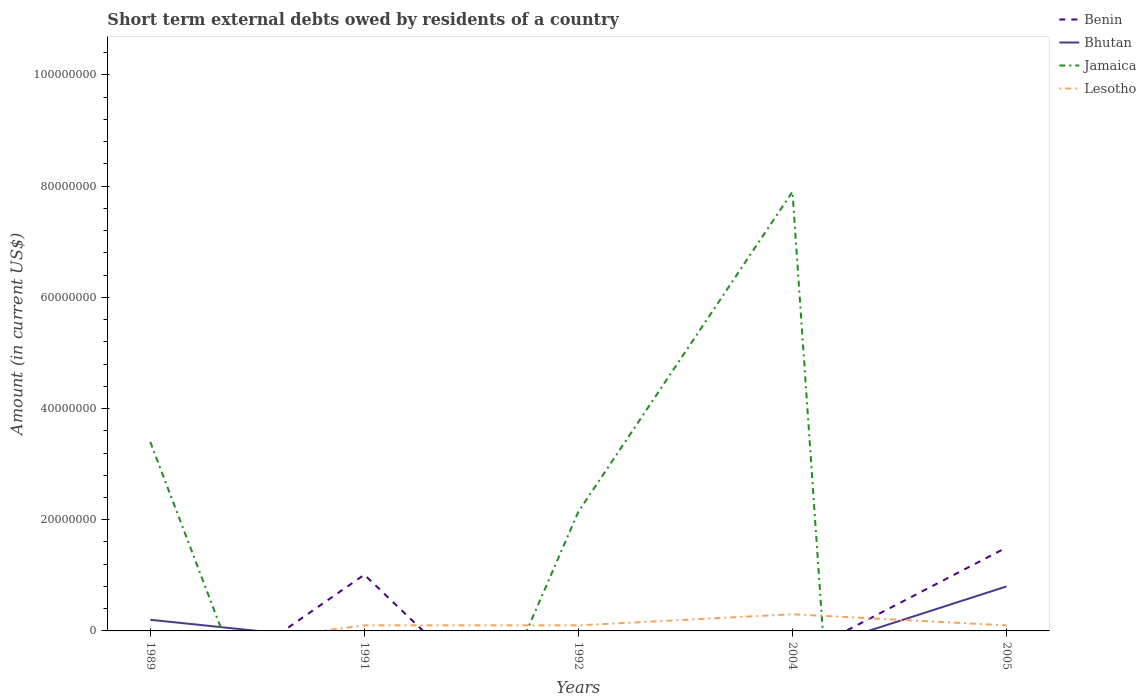How many different coloured lines are there?
Make the answer very short. 4. Does the line corresponding to Jamaica intersect with the line corresponding to Benin?
Make the answer very short. Yes. Is the number of lines equal to the number of legend labels?
Offer a very short reply. No. What is the total amount of short-term external debts owed by residents in Bhutan in the graph?
Make the answer very short. -5.99e+06. What is the difference between the highest and the second highest amount of short-term external debts owed by residents in Lesotho?
Offer a terse response. 3.00e+06. Is the amount of short-term external debts owed by residents in Lesotho strictly greater than the amount of short-term external debts owed by residents in Jamaica over the years?
Your answer should be compact. No. How many lines are there?
Offer a very short reply. 4. How many years are there in the graph?
Ensure brevity in your answer.  5. What is the difference between two consecutive major ticks on the Y-axis?
Offer a terse response. 2.00e+07. Does the graph contain any zero values?
Give a very brief answer. Yes. Does the graph contain grids?
Make the answer very short. No. How many legend labels are there?
Make the answer very short. 4. What is the title of the graph?
Make the answer very short. Short term external debts owed by residents of a country. What is the label or title of the X-axis?
Offer a very short reply. Years. What is the label or title of the Y-axis?
Provide a short and direct response. Amount (in current US$). What is the Amount (in current US$) in Benin in 1989?
Give a very brief answer. 0. What is the Amount (in current US$) in Bhutan in 1989?
Provide a succinct answer. 2.01e+06. What is the Amount (in current US$) in Jamaica in 1989?
Make the answer very short. 3.40e+07. What is the Amount (in current US$) in Benin in 1991?
Ensure brevity in your answer.  1.01e+07. What is the Amount (in current US$) in Jamaica in 1991?
Give a very brief answer. 0. What is the Amount (in current US$) of Lesotho in 1991?
Keep it short and to the point. 1.00e+06. What is the Amount (in current US$) of Bhutan in 1992?
Provide a succinct answer. 0. What is the Amount (in current US$) of Jamaica in 1992?
Give a very brief answer. 2.14e+07. What is the Amount (in current US$) of Lesotho in 1992?
Give a very brief answer. 1.00e+06. What is the Amount (in current US$) in Jamaica in 2004?
Give a very brief answer. 7.90e+07. What is the Amount (in current US$) of Lesotho in 2004?
Offer a very short reply. 3.00e+06. What is the Amount (in current US$) in Benin in 2005?
Your response must be concise. 1.50e+07. What is the Amount (in current US$) in Lesotho in 2005?
Provide a succinct answer. 1.00e+06. Across all years, what is the maximum Amount (in current US$) in Benin?
Ensure brevity in your answer.  1.50e+07. Across all years, what is the maximum Amount (in current US$) in Bhutan?
Give a very brief answer. 8.00e+06. Across all years, what is the maximum Amount (in current US$) in Jamaica?
Offer a terse response. 7.90e+07. Across all years, what is the minimum Amount (in current US$) of Benin?
Your answer should be compact. 0. Across all years, what is the minimum Amount (in current US$) of Jamaica?
Offer a very short reply. 0. What is the total Amount (in current US$) of Benin in the graph?
Make the answer very short. 2.51e+07. What is the total Amount (in current US$) in Bhutan in the graph?
Your answer should be compact. 1.00e+07. What is the total Amount (in current US$) in Jamaica in the graph?
Make the answer very short. 1.34e+08. What is the difference between the Amount (in current US$) in Jamaica in 1989 and that in 1992?
Offer a very short reply. 1.26e+07. What is the difference between the Amount (in current US$) in Jamaica in 1989 and that in 2004?
Give a very brief answer. -4.50e+07. What is the difference between the Amount (in current US$) in Bhutan in 1989 and that in 2005?
Ensure brevity in your answer.  -5.99e+06. What is the difference between the Amount (in current US$) in Lesotho in 1991 and that in 2004?
Your answer should be very brief. -2.00e+06. What is the difference between the Amount (in current US$) of Benin in 1991 and that in 2005?
Ensure brevity in your answer.  -4.89e+06. What is the difference between the Amount (in current US$) in Jamaica in 1992 and that in 2004?
Ensure brevity in your answer.  -5.76e+07. What is the difference between the Amount (in current US$) of Lesotho in 1992 and that in 2004?
Provide a short and direct response. -2.00e+06. What is the difference between the Amount (in current US$) in Lesotho in 2004 and that in 2005?
Provide a succinct answer. 2.00e+06. What is the difference between the Amount (in current US$) of Bhutan in 1989 and the Amount (in current US$) of Lesotho in 1991?
Make the answer very short. 1.01e+06. What is the difference between the Amount (in current US$) in Jamaica in 1989 and the Amount (in current US$) in Lesotho in 1991?
Provide a short and direct response. 3.30e+07. What is the difference between the Amount (in current US$) of Bhutan in 1989 and the Amount (in current US$) of Jamaica in 1992?
Ensure brevity in your answer.  -1.94e+07. What is the difference between the Amount (in current US$) of Bhutan in 1989 and the Amount (in current US$) of Lesotho in 1992?
Offer a terse response. 1.01e+06. What is the difference between the Amount (in current US$) in Jamaica in 1989 and the Amount (in current US$) in Lesotho in 1992?
Offer a very short reply. 3.30e+07. What is the difference between the Amount (in current US$) of Bhutan in 1989 and the Amount (in current US$) of Jamaica in 2004?
Give a very brief answer. -7.70e+07. What is the difference between the Amount (in current US$) of Bhutan in 1989 and the Amount (in current US$) of Lesotho in 2004?
Provide a short and direct response. -9.94e+05. What is the difference between the Amount (in current US$) in Jamaica in 1989 and the Amount (in current US$) in Lesotho in 2004?
Give a very brief answer. 3.10e+07. What is the difference between the Amount (in current US$) of Bhutan in 1989 and the Amount (in current US$) of Lesotho in 2005?
Ensure brevity in your answer.  1.01e+06. What is the difference between the Amount (in current US$) of Jamaica in 1989 and the Amount (in current US$) of Lesotho in 2005?
Give a very brief answer. 3.30e+07. What is the difference between the Amount (in current US$) of Benin in 1991 and the Amount (in current US$) of Jamaica in 1992?
Your answer should be very brief. -1.13e+07. What is the difference between the Amount (in current US$) of Benin in 1991 and the Amount (in current US$) of Lesotho in 1992?
Offer a very short reply. 9.11e+06. What is the difference between the Amount (in current US$) of Benin in 1991 and the Amount (in current US$) of Jamaica in 2004?
Make the answer very short. -6.89e+07. What is the difference between the Amount (in current US$) in Benin in 1991 and the Amount (in current US$) in Lesotho in 2004?
Provide a succinct answer. 7.11e+06. What is the difference between the Amount (in current US$) of Benin in 1991 and the Amount (in current US$) of Bhutan in 2005?
Make the answer very short. 2.11e+06. What is the difference between the Amount (in current US$) in Benin in 1991 and the Amount (in current US$) in Lesotho in 2005?
Your answer should be compact. 9.11e+06. What is the difference between the Amount (in current US$) of Jamaica in 1992 and the Amount (in current US$) of Lesotho in 2004?
Ensure brevity in your answer.  1.84e+07. What is the difference between the Amount (in current US$) in Jamaica in 1992 and the Amount (in current US$) in Lesotho in 2005?
Provide a short and direct response. 2.04e+07. What is the difference between the Amount (in current US$) of Jamaica in 2004 and the Amount (in current US$) of Lesotho in 2005?
Make the answer very short. 7.80e+07. What is the average Amount (in current US$) of Benin per year?
Provide a short and direct response. 5.02e+06. What is the average Amount (in current US$) in Bhutan per year?
Your answer should be very brief. 2.00e+06. What is the average Amount (in current US$) of Jamaica per year?
Your answer should be compact. 2.69e+07. What is the average Amount (in current US$) in Lesotho per year?
Make the answer very short. 1.20e+06. In the year 1989, what is the difference between the Amount (in current US$) in Bhutan and Amount (in current US$) in Jamaica?
Offer a very short reply. -3.20e+07. In the year 1991, what is the difference between the Amount (in current US$) of Benin and Amount (in current US$) of Lesotho?
Provide a succinct answer. 9.11e+06. In the year 1992, what is the difference between the Amount (in current US$) in Jamaica and Amount (in current US$) in Lesotho?
Offer a very short reply. 2.04e+07. In the year 2004, what is the difference between the Amount (in current US$) in Jamaica and Amount (in current US$) in Lesotho?
Provide a short and direct response. 7.60e+07. In the year 2005, what is the difference between the Amount (in current US$) of Benin and Amount (in current US$) of Bhutan?
Provide a short and direct response. 7.00e+06. In the year 2005, what is the difference between the Amount (in current US$) in Benin and Amount (in current US$) in Lesotho?
Offer a very short reply. 1.40e+07. What is the ratio of the Amount (in current US$) in Jamaica in 1989 to that in 1992?
Keep it short and to the point. 1.59. What is the ratio of the Amount (in current US$) in Jamaica in 1989 to that in 2004?
Provide a short and direct response. 0.43. What is the ratio of the Amount (in current US$) in Bhutan in 1989 to that in 2005?
Ensure brevity in your answer.  0.25. What is the ratio of the Amount (in current US$) in Lesotho in 1991 to that in 1992?
Provide a succinct answer. 1. What is the ratio of the Amount (in current US$) of Lesotho in 1991 to that in 2004?
Make the answer very short. 0.33. What is the ratio of the Amount (in current US$) in Benin in 1991 to that in 2005?
Your answer should be very brief. 0.67. What is the ratio of the Amount (in current US$) of Lesotho in 1991 to that in 2005?
Keep it short and to the point. 1. What is the ratio of the Amount (in current US$) of Jamaica in 1992 to that in 2004?
Make the answer very short. 0.27. What is the ratio of the Amount (in current US$) of Lesotho in 1992 to that in 2005?
Give a very brief answer. 1. What is the ratio of the Amount (in current US$) of Lesotho in 2004 to that in 2005?
Offer a very short reply. 3. What is the difference between the highest and the second highest Amount (in current US$) in Jamaica?
Your response must be concise. 4.50e+07. What is the difference between the highest and the second highest Amount (in current US$) of Lesotho?
Provide a short and direct response. 2.00e+06. What is the difference between the highest and the lowest Amount (in current US$) of Benin?
Make the answer very short. 1.50e+07. What is the difference between the highest and the lowest Amount (in current US$) in Bhutan?
Make the answer very short. 8.00e+06. What is the difference between the highest and the lowest Amount (in current US$) in Jamaica?
Offer a very short reply. 7.90e+07. What is the difference between the highest and the lowest Amount (in current US$) in Lesotho?
Offer a terse response. 3.00e+06. 